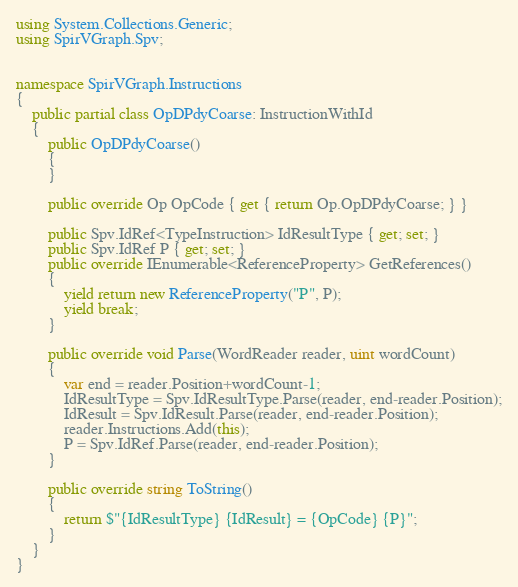<code> <loc_0><loc_0><loc_500><loc_500><_C#_>using System.Collections.Generic;
using SpirVGraph.Spv;


namespace SpirVGraph.Instructions
{
    public partial class OpDPdyCoarse: InstructionWithId
    {
        public OpDPdyCoarse()
        {
        }

        public override Op OpCode { get { return Op.OpDPdyCoarse; } }

		public Spv.IdRef<TypeInstruction> IdResultType { get; set; }
		public Spv.IdRef P { get; set; }
        public override IEnumerable<ReferenceProperty> GetReferences()
		{
		    yield return new ReferenceProperty("P", P);
		    yield break;
		}

        public override void Parse(WordReader reader, uint wordCount)
        {
			var end = reader.Position+wordCount-1;
		    IdResultType = Spv.IdResultType.Parse(reader, end-reader.Position);
		    IdResult = Spv.IdResult.Parse(reader, end-reader.Position);
            reader.Instructions.Add(this);
		    P = Spv.IdRef.Parse(reader, end-reader.Position);
        }

        public override string ToString()
        {
            return $"{IdResultType} {IdResult} = {OpCode} {P}";
        }
    }
}
</code> 